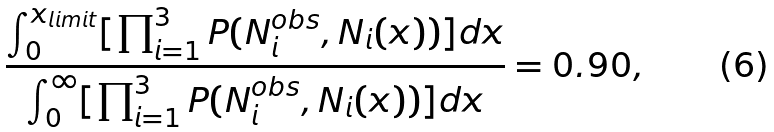<formula> <loc_0><loc_0><loc_500><loc_500>\frac { \int _ { 0 } ^ { x _ { l i m i t } } [ \prod _ { i = 1 } ^ { 3 } P ( N ^ { o b s } _ { i } , N _ { i } ( x ) ) ] d x } { \int _ { 0 } ^ { \infty } [ \prod _ { i = 1 } ^ { 3 } P ( N ^ { o b s } _ { i } , N _ { i } ( x ) ) ] d x } = 0 . 9 0 ,</formula> 